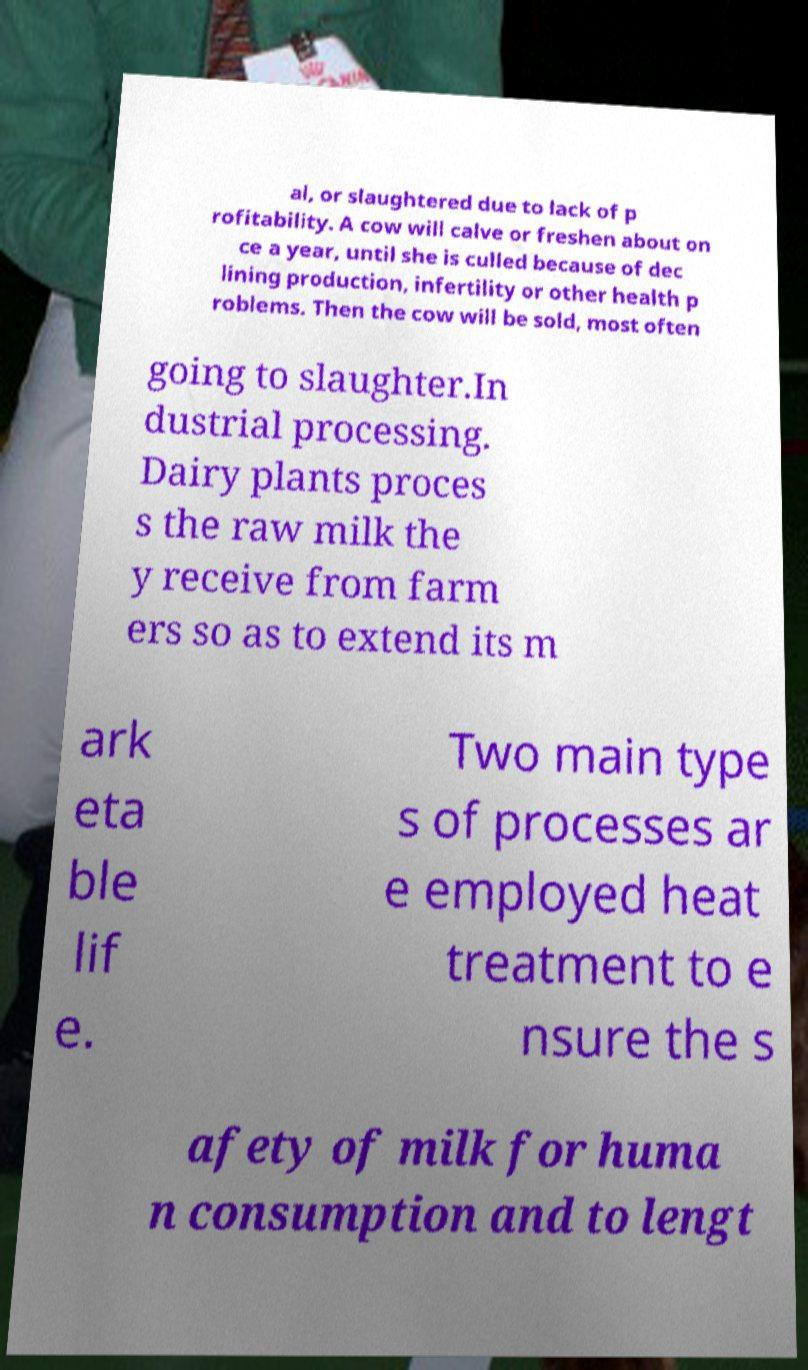Could you assist in decoding the text presented in this image and type it out clearly? al, or slaughtered due to lack of p rofitability. A cow will calve or freshen about on ce a year, until she is culled because of dec lining production, infertility or other health p roblems. Then the cow will be sold, most often going to slaughter.In dustrial processing. Dairy plants proces s the raw milk the y receive from farm ers so as to extend its m ark eta ble lif e. Two main type s of processes ar e employed heat treatment to e nsure the s afety of milk for huma n consumption and to lengt 